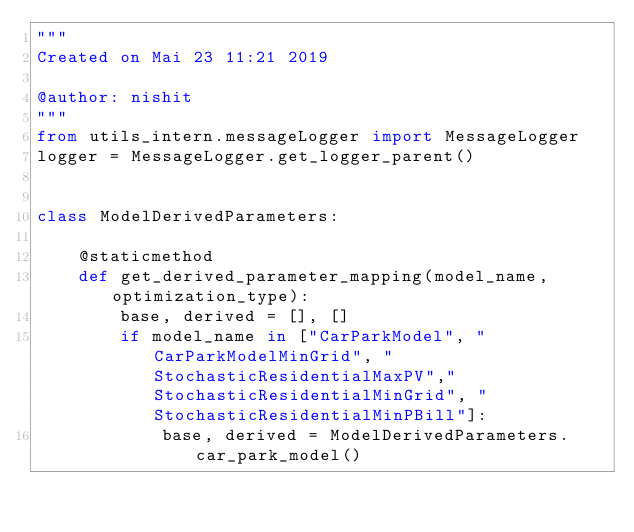Convert code to text. <code><loc_0><loc_0><loc_500><loc_500><_Python_>"""
Created on Mai 23 11:21 2019

@author: nishit
"""
from utils_intern.messageLogger import MessageLogger
logger = MessageLogger.get_logger_parent()


class ModelDerivedParameters:

    @staticmethod
    def get_derived_parameter_mapping(model_name, optimization_type):
        base, derived = [], []
        if model_name in ["CarParkModel", "CarParkModelMinGrid", "StochasticResidentialMaxPV","StochasticResidentialMinGrid", "StochasticResidentialMinPBill"]:
            base, derived = ModelDerivedParameters.car_park_model()</code> 